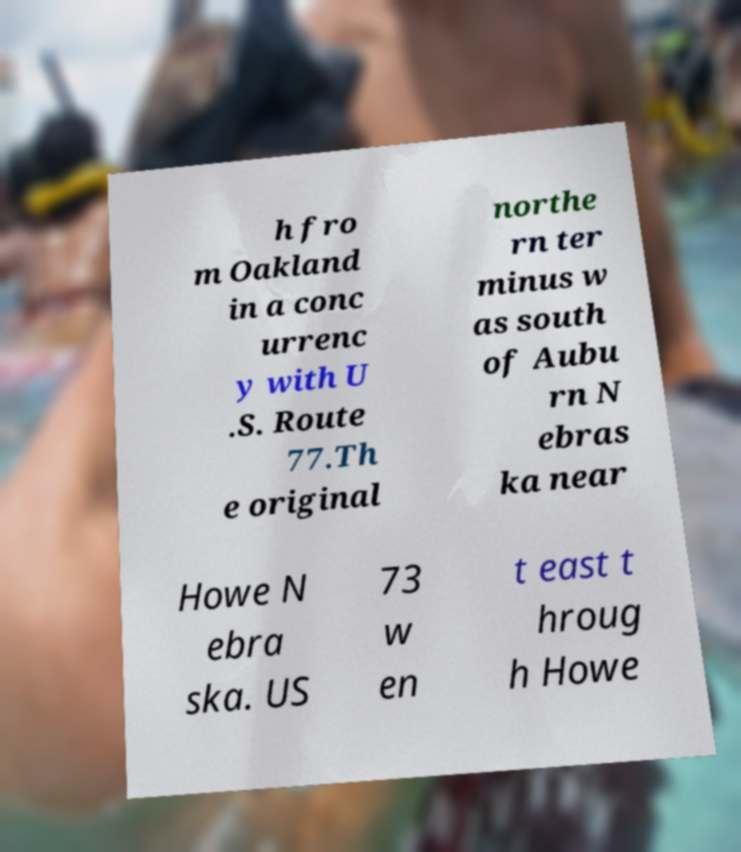Could you extract and type out the text from this image? h fro m Oakland in a conc urrenc y with U .S. Route 77.Th e original northe rn ter minus w as south of Aubu rn N ebras ka near Howe N ebra ska. US 73 w en t east t hroug h Howe 